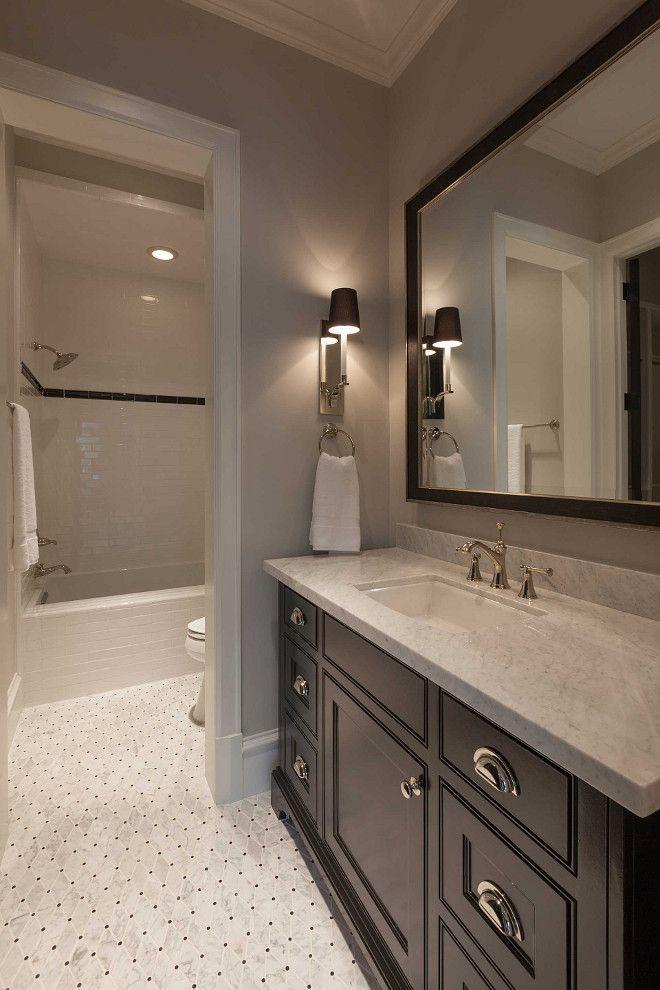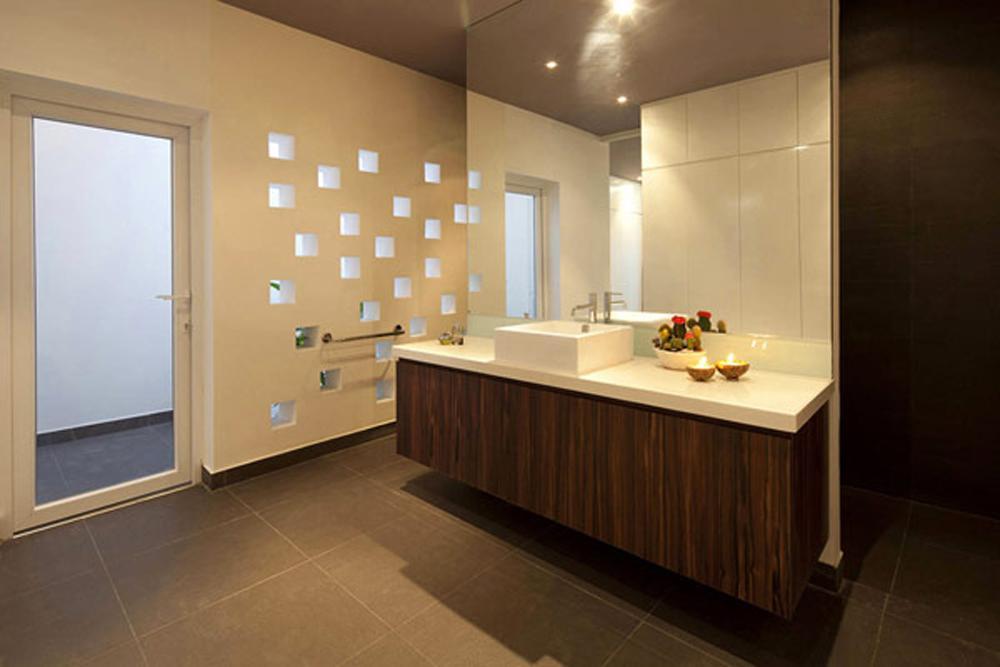The first image is the image on the left, the second image is the image on the right. Considering the images on both sides, is "A commode is positioned in front of one side of a bathroom vanity, with a sink installed beside it in a wider area over a storage space." valid? Answer yes or no. No. The first image is the image on the left, the second image is the image on the right. For the images shown, is this caption "A cabinet sits behind a toilet in the image on the right." true? Answer yes or no. No. 